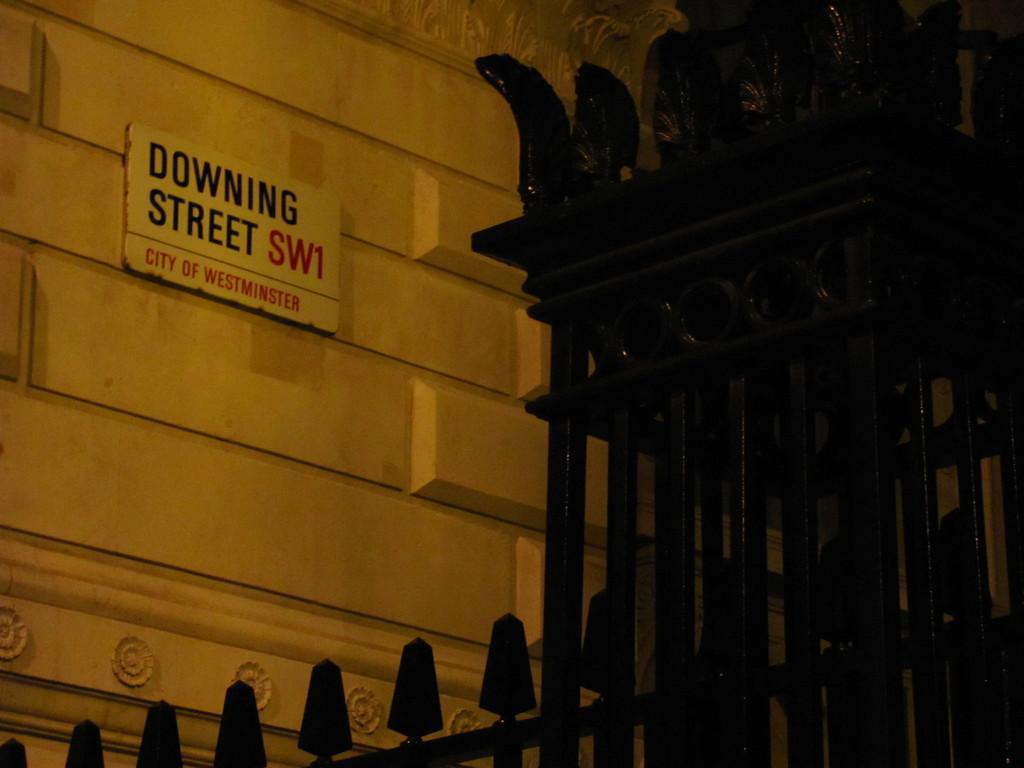Can you describe this image briefly? In this image we can see a wall to which some board is attached on which it is written as downing street and on right side of the image we can see black color rods which are in some structure. 